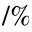<formula> <loc_0><loc_0><loc_500><loc_500>\slash \%</formula> 